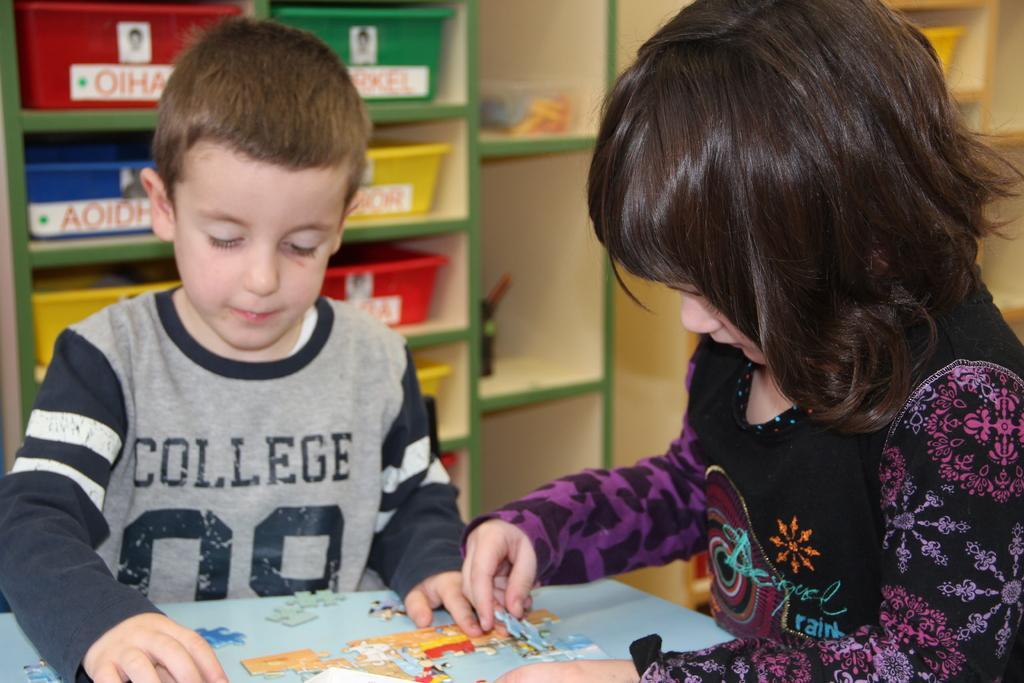Describe this image in one or two sentences. On the left side a kid is trying to fix the puzzle in it. On the right side there is a girl also doing the same. 